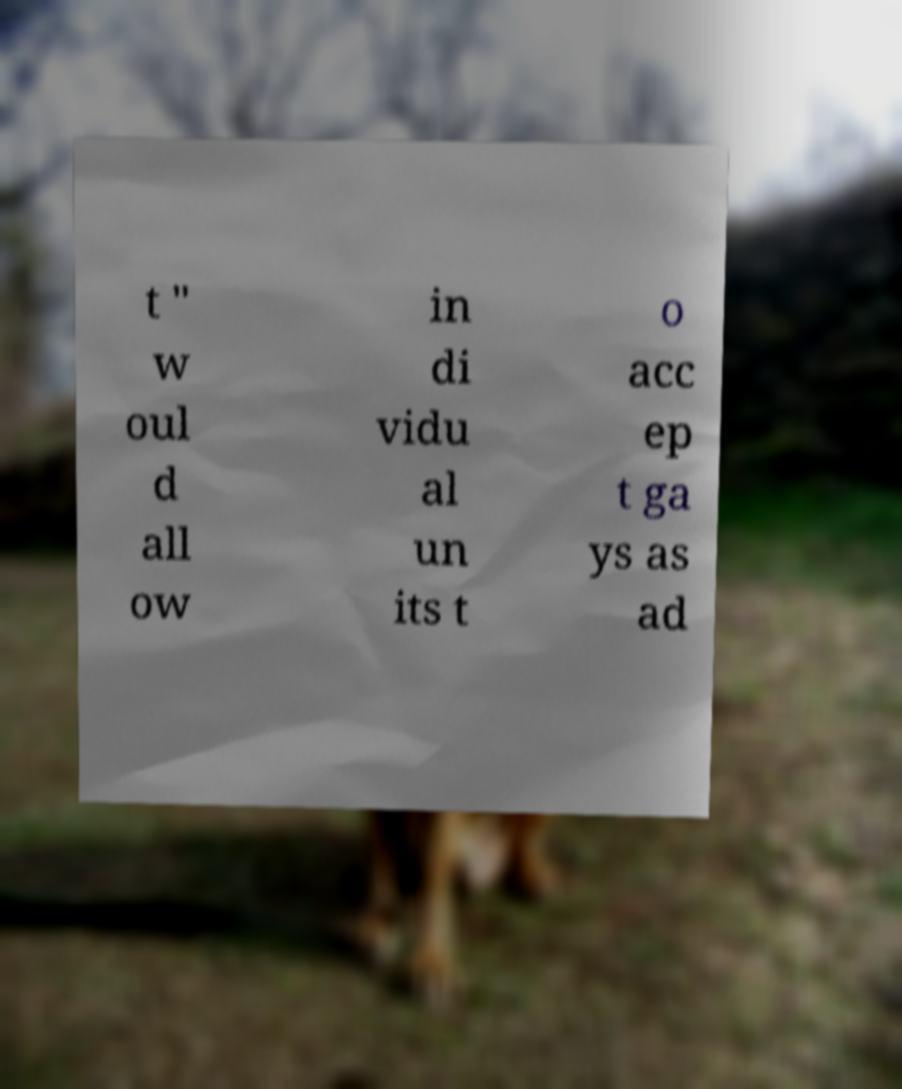Please read and relay the text visible in this image. What does it say? t " w oul d all ow in di vidu al un its t o acc ep t ga ys as ad 